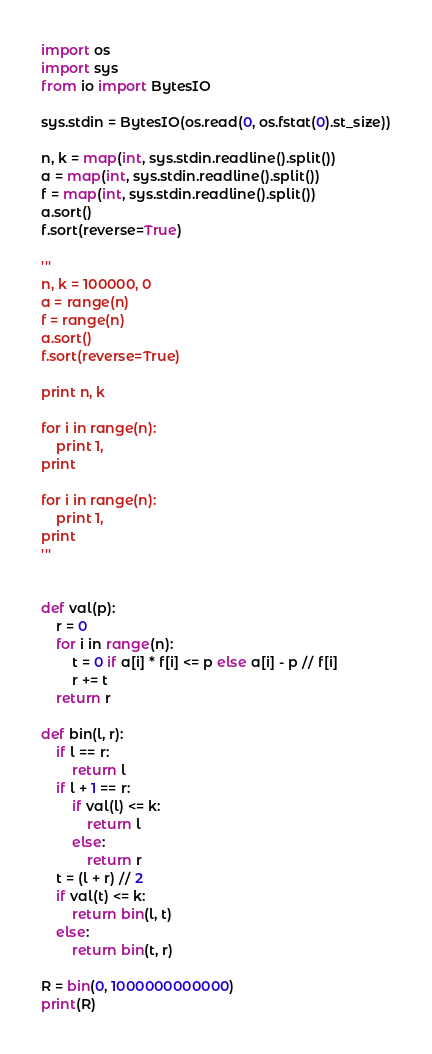Convert code to text. <code><loc_0><loc_0><loc_500><loc_500><_Python_>import os
import sys
from io import BytesIO

sys.stdin = BytesIO(os.read(0, os.fstat(0).st_size))

n, k = map(int, sys.stdin.readline().split())
a = map(int, sys.stdin.readline().split())
f = map(int, sys.stdin.readline().split())
a.sort()
f.sort(reverse=True)

'''
n, k = 100000, 0
a = range(n)
f = range(n)
a.sort()
f.sort(reverse=True)

print n, k

for i in range(n):
	print 1,
print

for i in range(n):
	print 1,
print
'''


def val(p):
	r = 0
	for i in range(n):
		t = 0 if a[i] * f[i] <= p else a[i] - p // f[i]
		r += t
	return r
		
def bin(l, r):
	if l == r:
		return l
	if l + 1 == r:
		if val(l) <= k:
			return l
		else:
			return r
	t = (l + r) // 2
	if val(t) <= k:
		return bin(l, t)
	else:
		return bin(t, r)
		
R = bin(0, 1000000000000)
print(R)</code> 